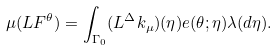<formula> <loc_0><loc_0><loc_500><loc_500>\mu ( L F ^ { \theta } ) = \int _ { \Gamma _ { 0 } } ( L ^ { \Delta } k _ { \mu } ) ( \eta ) e ( \theta ; \eta ) \lambda ( d \eta ) .</formula> 